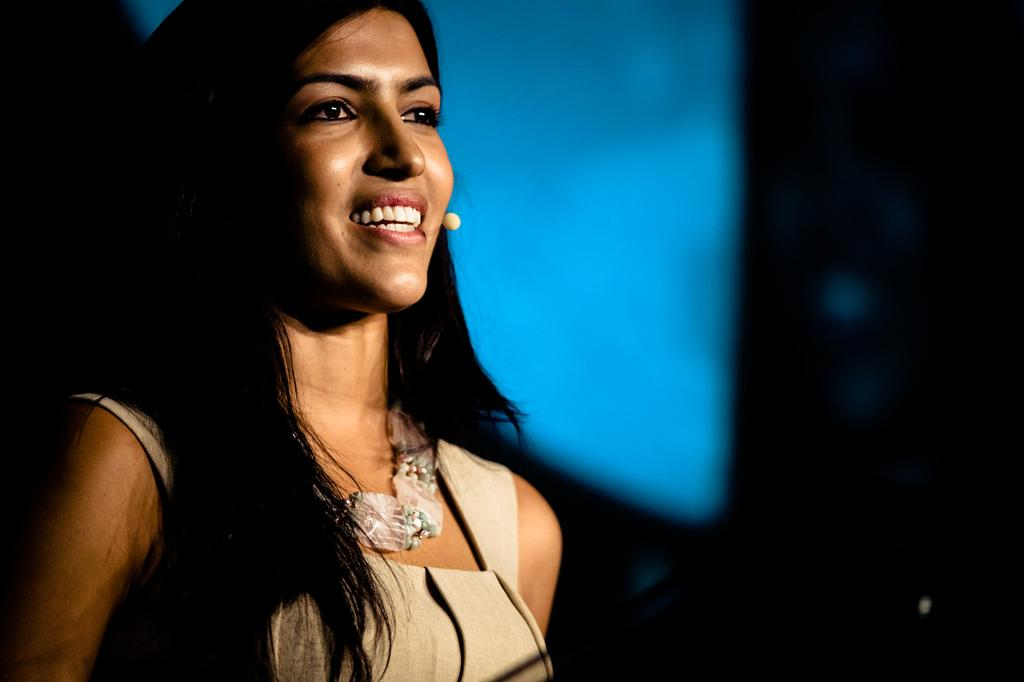Who is the main subject in the image? There is a woman in the image. What is the woman wearing? The woman is wearing a cream-colored dress. Can you describe the woman's hairstyle? The woman has loose hair. What is the woman's facial expression? The woman is smiling. What can be seen in the background of the image? There is a blue screen in the background, but it is not clearly visible. What type of ice can be seen melting on the woman's shoulder in the image? There is no ice visible in the image; the woman is wearing a cream-colored dress. 